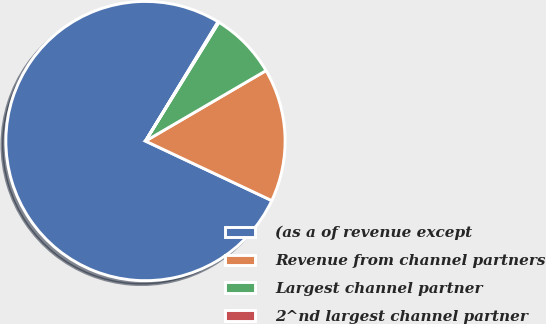Convert chart to OTSL. <chart><loc_0><loc_0><loc_500><loc_500><pie_chart><fcel>(as a of revenue except<fcel>Revenue from channel partners<fcel>Largest channel partner<fcel>2^nd largest channel partner<nl><fcel>76.69%<fcel>15.43%<fcel>7.77%<fcel>0.11%<nl></chart> 